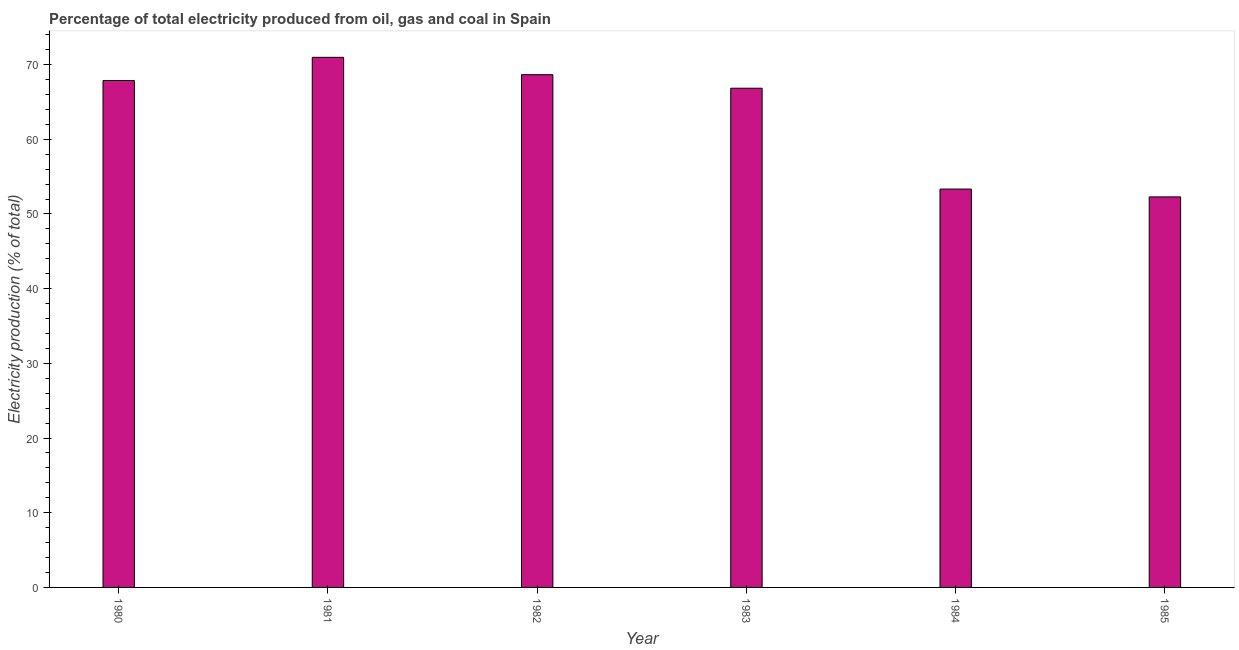Does the graph contain any zero values?
Your answer should be compact. No. Does the graph contain grids?
Ensure brevity in your answer.  No. What is the title of the graph?
Make the answer very short. Percentage of total electricity produced from oil, gas and coal in Spain. What is the label or title of the Y-axis?
Your response must be concise. Electricity production (% of total). What is the electricity production in 1980?
Offer a very short reply. 67.87. Across all years, what is the maximum electricity production?
Provide a short and direct response. 70.97. Across all years, what is the minimum electricity production?
Provide a short and direct response. 52.28. In which year was the electricity production maximum?
Offer a terse response. 1981. What is the sum of the electricity production?
Provide a short and direct response. 379.92. What is the difference between the electricity production in 1980 and 1985?
Keep it short and to the point. 15.59. What is the average electricity production per year?
Make the answer very short. 63.32. What is the median electricity production?
Provide a succinct answer. 67.35. Do a majority of the years between 1982 and 1980 (inclusive) have electricity production greater than 26 %?
Make the answer very short. Yes. What is the ratio of the electricity production in 1983 to that in 1984?
Offer a very short reply. 1.25. Is the electricity production in 1980 less than that in 1982?
Provide a short and direct response. Yes. What is the difference between the highest and the second highest electricity production?
Provide a succinct answer. 2.32. Is the sum of the electricity production in 1980 and 1985 greater than the maximum electricity production across all years?
Ensure brevity in your answer.  Yes. What is the difference between the highest and the lowest electricity production?
Offer a terse response. 18.69. How many bars are there?
Offer a very short reply. 6. Are all the bars in the graph horizontal?
Offer a very short reply. No. What is the difference between two consecutive major ticks on the Y-axis?
Offer a very short reply. 10. What is the Electricity production (% of total) of 1980?
Provide a short and direct response. 67.87. What is the Electricity production (% of total) of 1981?
Offer a very short reply. 70.97. What is the Electricity production (% of total) in 1982?
Your answer should be very brief. 68.65. What is the Electricity production (% of total) of 1983?
Offer a very short reply. 66.83. What is the Electricity production (% of total) in 1984?
Offer a very short reply. 53.33. What is the Electricity production (% of total) of 1985?
Keep it short and to the point. 52.28. What is the difference between the Electricity production (% of total) in 1980 and 1981?
Provide a short and direct response. -3.1. What is the difference between the Electricity production (% of total) in 1980 and 1982?
Provide a short and direct response. -0.78. What is the difference between the Electricity production (% of total) in 1980 and 1983?
Your response must be concise. 1.03. What is the difference between the Electricity production (% of total) in 1980 and 1984?
Keep it short and to the point. 14.54. What is the difference between the Electricity production (% of total) in 1980 and 1985?
Your answer should be very brief. 15.58. What is the difference between the Electricity production (% of total) in 1981 and 1982?
Your answer should be compact. 2.32. What is the difference between the Electricity production (% of total) in 1981 and 1983?
Offer a terse response. 4.14. What is the difference between the Electricity production (% of total) in 1981 and 1984?
Keep it short and to the point. 17.64. What is the difference between the Electricity production (% of total) in 1981 and 1985?
Provide a succinct answer. 18.69. What is the difference between the Electricity production (% of total) in 1982 and 1983?
Provide a short and direct response. 1.81. What is the difference between the Electricity production (% of total) in 1982 and 1984?
Offer a terse response. 15.32. What is the difference between the Electricity production (% of total) in 1982 and 1985?
Make the answer very short. 16.36. What is the difference between the Electricity production (% of total) in 1983 and 1984?
Provide a short and direct response. 13.5. What is the difference between the Electricity production (% of total) in 1983 and 1985?
Offer a very short reply. 14.55. What is the difference between the Electricity production (% of total) in 1984 and 1985?
Offer a terse response. 1.05. What is the ratio of the Electricity production (% of total) in 1980 to that in 1981?
Offer a very short reply. 0.96. What is the ratio of the Electricity production (% of total) in 1980 to that in 1983?
Offer a terse response. 1.01. What is the ratio of the Electricity production (% of total) in 1980 to that in 1984?
Give a very brief answer. 1.27. What is the ratio of the Electricity production (% of total) in 1980 to that in 1985?
Offer a terse response. 1.3. What is the ratio of the Electricity production (% of total) in 1981 to that in 1982?
Your answer should be very brief. 1.03. What is the ratio of the Electricity production (% of total) in 1981 to that in 1983?
Provide a succinct answer. 1.06. What is the ratio of the Electricity production (% of total) in 1981 to that in 1984?
Ensure brevity in your answer.  1.33. What is the ratio of the Electricity production (% of total) in 1981 to that in 1985?
Your answer should be compact. 1.36. What is the ratio of the Electricity production (% of total) in 1982 to that in 1983?
Offer a very short reply. 1.03. What is the ratio of the Electricity production (% of total) in 1982 to that in 1984?
Offer a very short reply. 1.29. What is the ratio of the Electricity production (% of total) in 1982 to that in 1985?
Make the answer very short. 1.31. What is the ratio of the Electricity production (% of total) in 1983 to that in 1984?
Make the answer very short. 1.25. What is the ratio of the Electricity production (% of total) in 1983 to that in 1985?
Your answer should be compact. 1.28. 